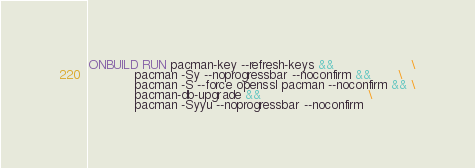<code> <loc_0><loc_0><loc_500><loc_500><_Dockerfile_>ONBUILD RUN pacman-key --refresh-keys &&                    \
            pacman -Sy --noprogressbar --noconfirm &&       \
            pacman -S --force openssl pacman --noconfirm && \
            pacman-db-upgrade &&                            \
            pacman -Syyu --noprogressbar --noconfirm
</code> 